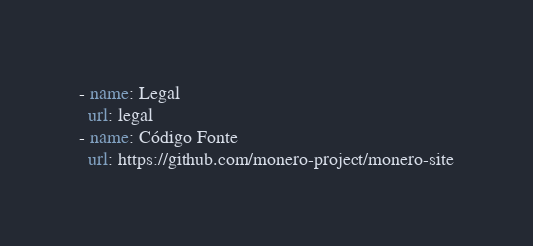<code> <loc_0><loc_0><loc_500><loc_500><_YAML_>- name: Legal
  url: legal
- name: Código Fonte
  url: https://github.com/monero-project/monero-site
</code> 